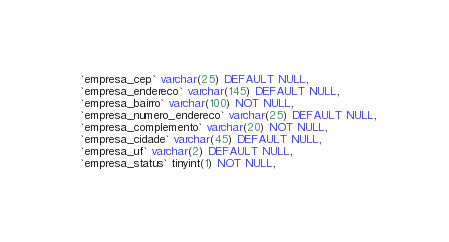Convert code to text. <code><loc_0><loc_0><loc_500><loc_500><_SQL_>  `empresa_cep` varchar(25) DEFAULT NULL,
  `empresa_endereco` varchar(145) DEFAULT NULL,
  `empresa_bairro` varchar(100) NOT NULL,
  `empresa_numero_endereco` varchar(25) DEFAULT NULL,
  `empresa_complemento` varchar(20) NOT NULL,
  `empresa_cidade` varchar(45) DEFAULT NULL,
  `empresa_uf` varchar(2) DEFAULT NULL,
  `empresa_status` tinyint(1) NOT NULL,</code> 